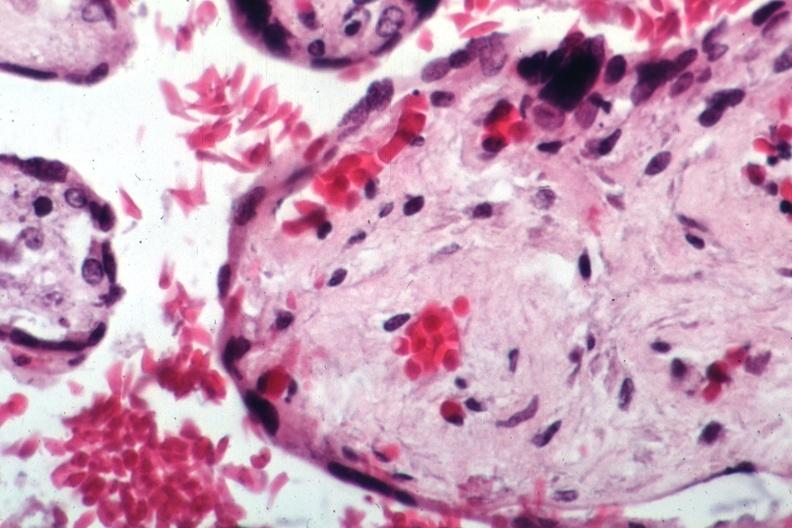s adrenal of premature 30 week gestation gram infant lesion present?
Answer the question using a single word or phrase. No 